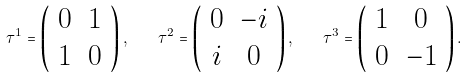Convert formula to latex. <formula><loc_0><loc_0><loc_500><loc_500>\tau ^ { 1 } = \left ( \begin{array} { c c } 0 & 1 \\ 1 & 0 \end{array} \right ) , \quad \tau ^ { 2 } = \left ( \begin{array} { c c } 0 & - i \\ i & 0 \end{array} \right ) , \quad \tau ^ { 3 } = \left ( \begin{array} { c c } 1 & 0 \\ 0 & - 1 \end{array} \right ) .</formula> 